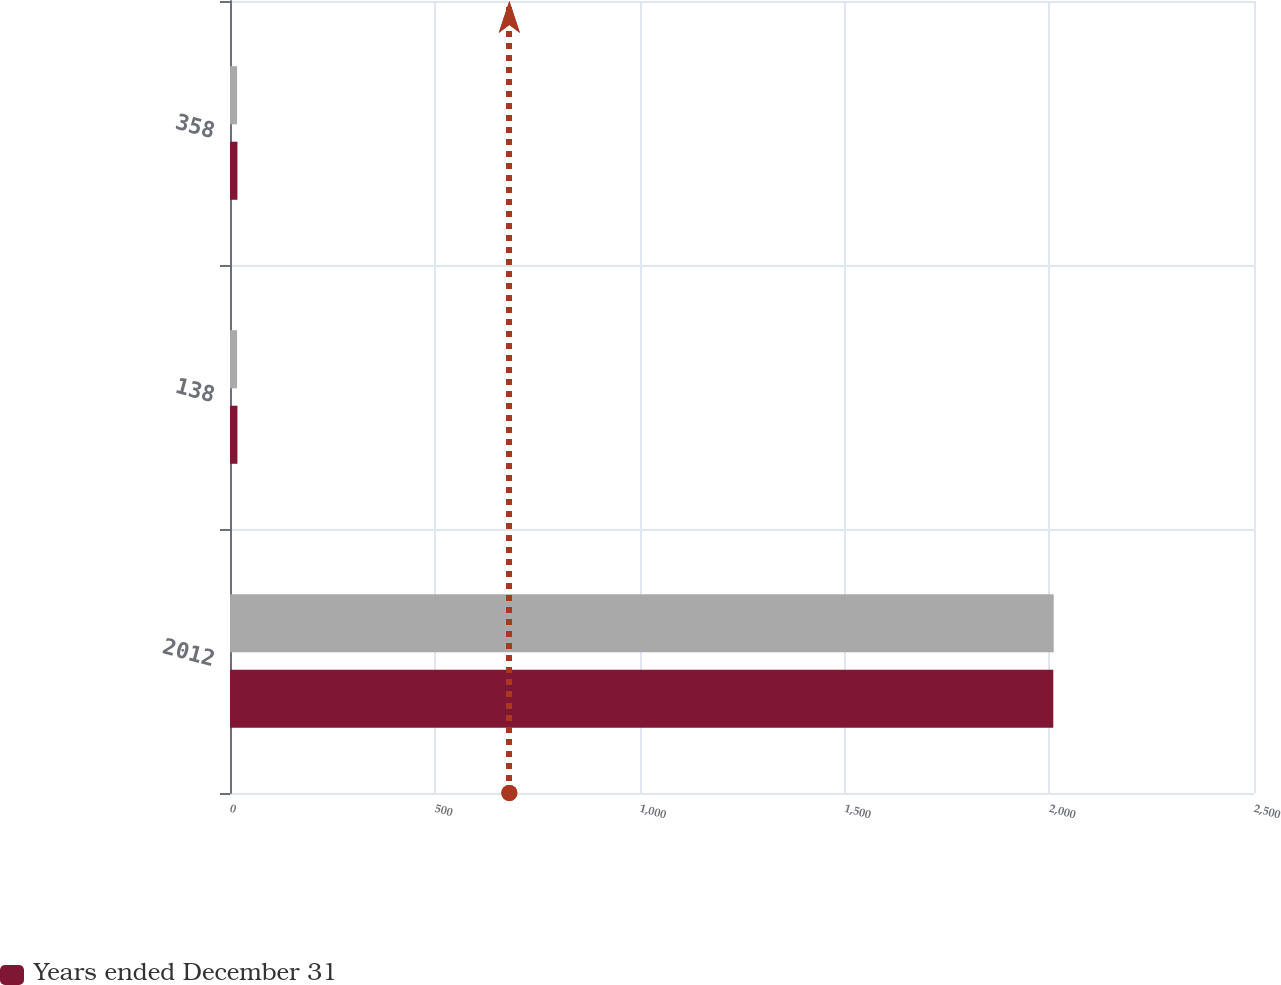<chart> <loc_0><loc_0><loc_500><loc_500><stacked_bar_chart><ecel><fcel>2012<fcel>138<fcel>358<nl><fcel>nan<fcel>2011<fcel>17.3<fcel>17.3<nl><fcel>Years ended December 31<fcel>2010<fcel>18.2<fcel>18.2<nl></chart> 